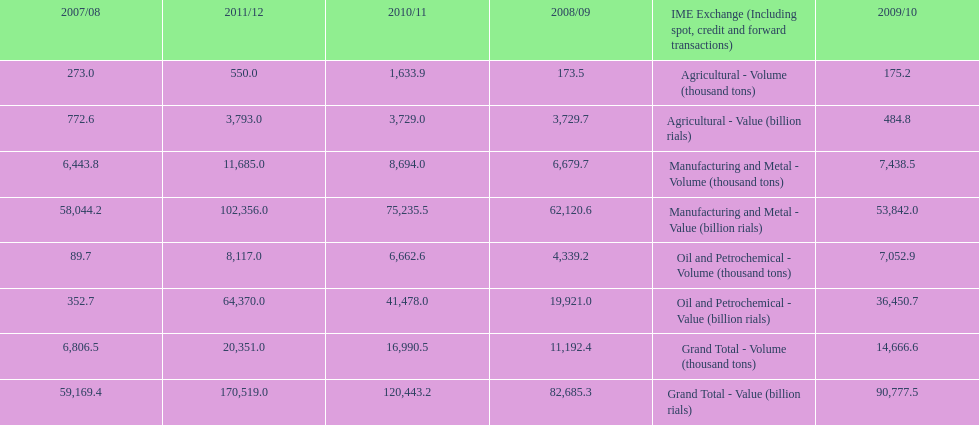What year saw the greatest value for manufacturing and metal in iran? 2011/12. 